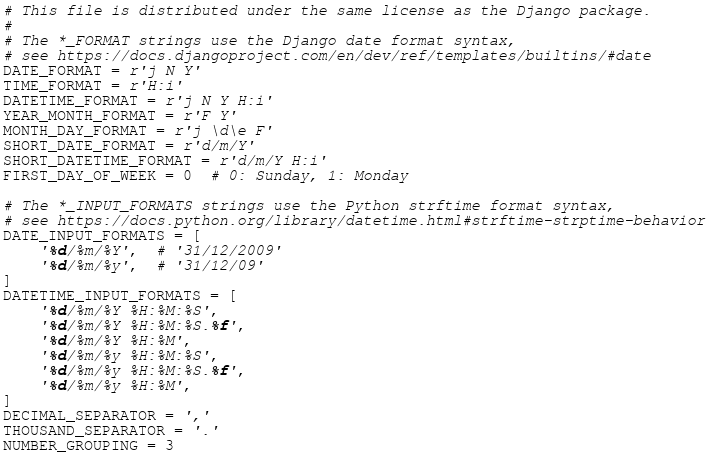<code> <loc_0><loc_0><loc_500><loc_500><_Python_># This file is distributed under the same license as the Django package.
#
# The *_FORMAT strings use the Django date format syntax,
# see https://docs.djangoproject.com/en/dev/ref/templates/builtins/#date
DATE_FORMAT = r'j N Y'
TIME_FORMAT = r'H:i'
DATETIME_FORMAT = r'j N Y H:i'
YEAR_MONTH_FORMAT = r'F Y'
MONTH_DAY_FORMAT = r'j \d\e F'
SHORT_DATE_FORMAT = r'd/m/Y'
SHORT_DATETIME_FORMAT = r'd/m/Y H:i'
FIRST_DAY_OF_WEEK = 0  # 0: Sunday, 1: Monday

# The *_INPUT_FORMATS strings use the Python strftime format syntax,
# see https://docs.python.org/library/datetime.html#strftime-strptime-behavior
DATE_INPUT_FORMATS = [
    '%d/%m/%Y',  # '31/12/2009'
    '%d/%m/%y',  # '31/12/09'
]
DATETIME_INPUT_FORMATS = [
    '%d/%m/%Y %H:%M:%S',
    '%d/%m/%Y %H:%M:%S.%f',
    '%d/%m/%Y %H:%M',
    '%d/%m/%y %H:%M:%S',
    '%d/%m/%y %H:%M:%S.%f',
    '%d/%m/%y %H:%M',
]
DECIMAL_SEPARATOR = ','
THOUSAND_SEPARATOR = '.'
NUMBER_GROUPING = 3
</code> 